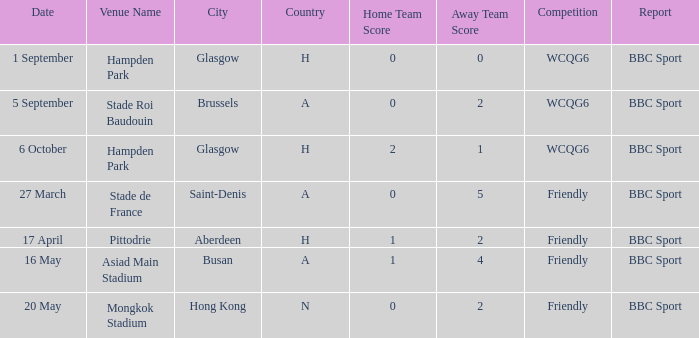Which individual gave an account of the game held on september 1st? BBC Sport. 